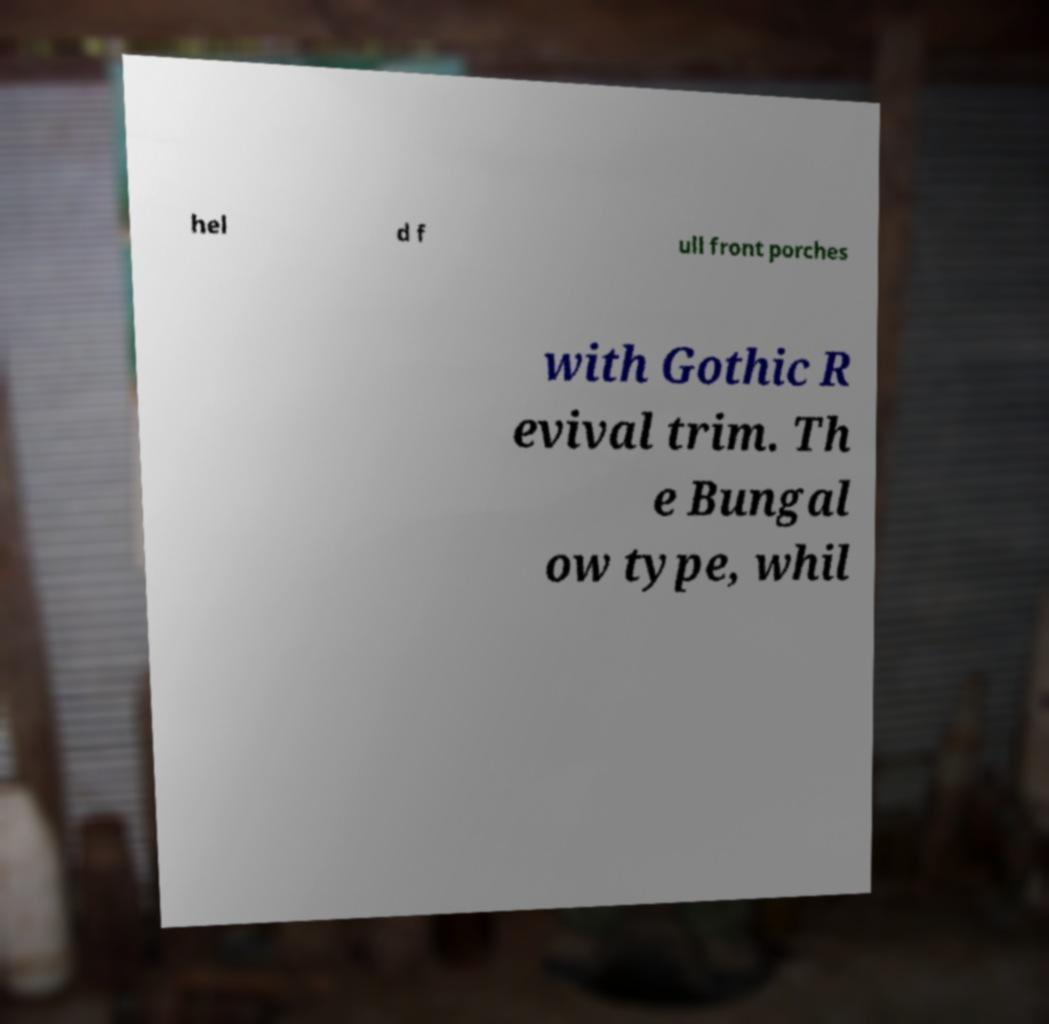Please identify and transcribe the text found in this image. hel d f ull front porches with Gothic R evival trim. Th e Bungal ow type, whil 